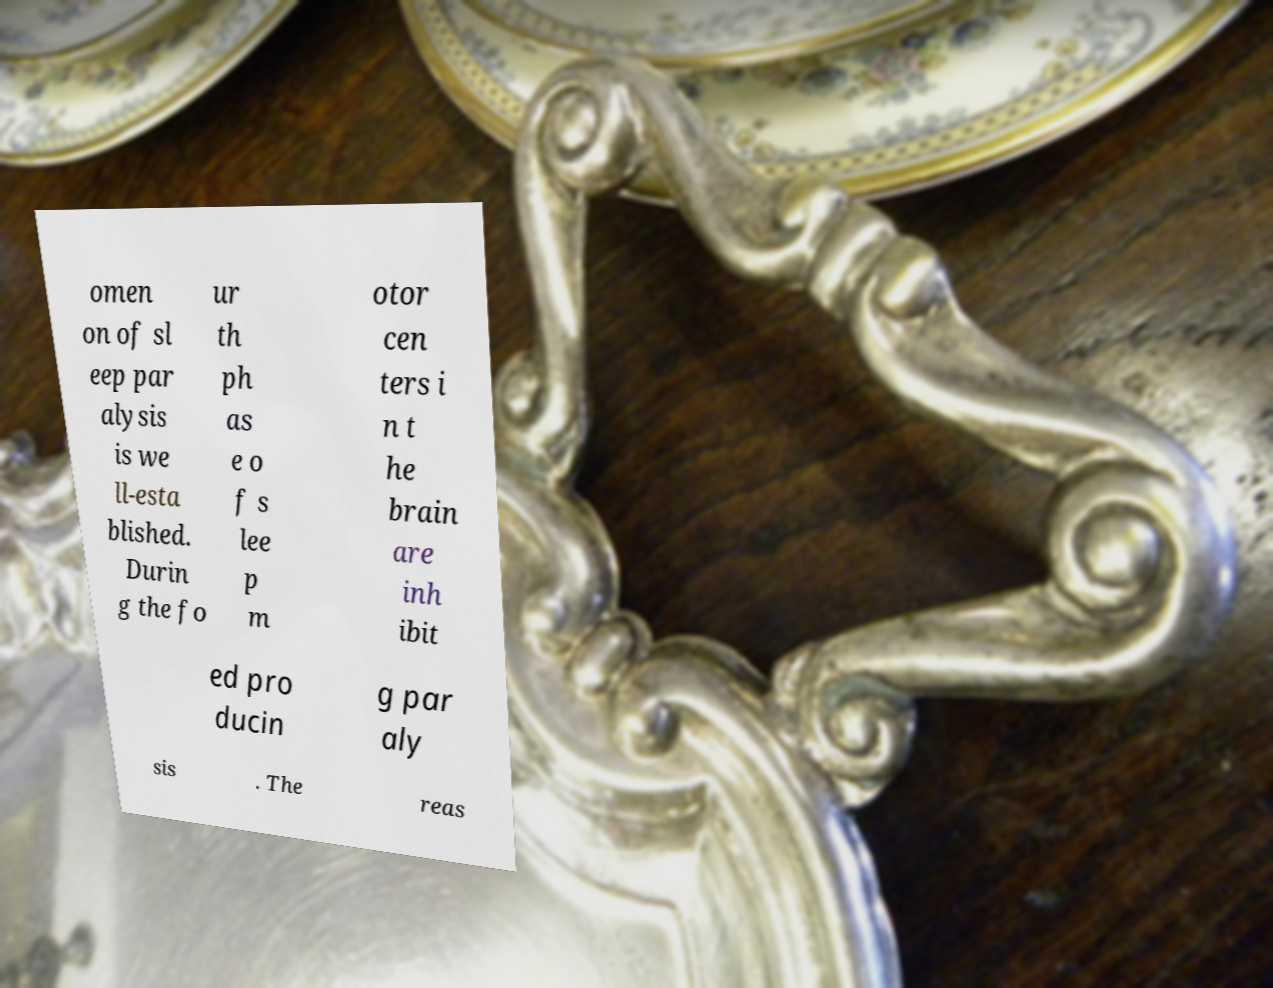Can you read and provide the text displayed in the image?This photo seems to have some interesting text. Can you extract and type it out for me? omen on of sl eep par alysis is we ll-esta blished. Durin g the fo ur th ph as e o f s lee p m otor cen ters i n t he brain are inh ibit ed pro ducin g par aly sis . The reas 